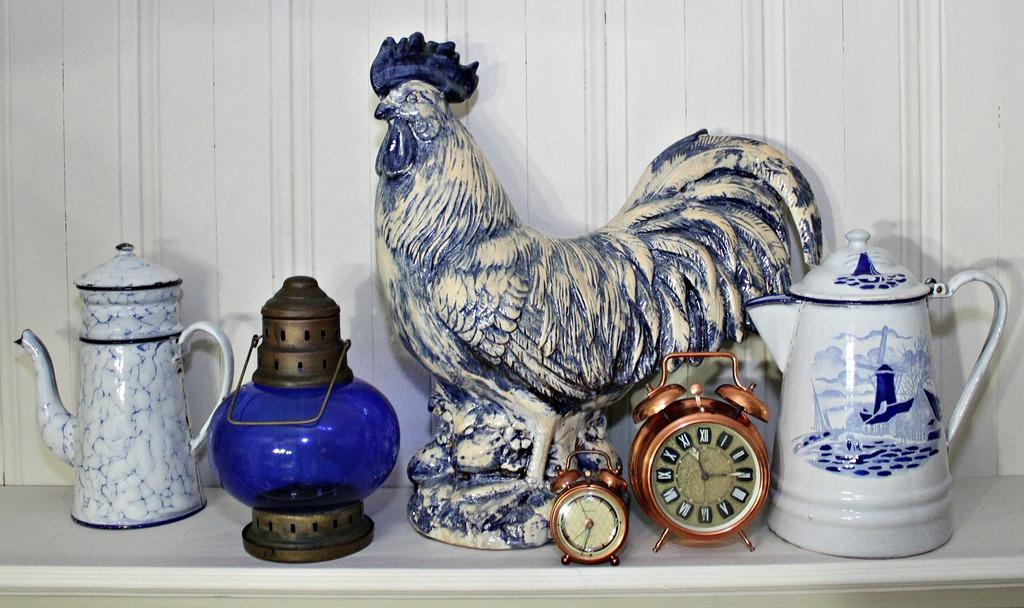What type of objects can be seen in the image? There are jugs, a lantern, clocks, and a sculpture of a roaster in the image. Can you describe the lantern in the image? The lantern in the image is a source of light. What might the clocks in the image be used for? The clocks in the image might be used for telling time. What is the sculpture of in the image? The sculpture in the image is of a roaster. Can you tell me how many zebras are depicted in the image? There are no zebras present in the image. What type of horse can be seen in the image? There is no horse present in the image. 